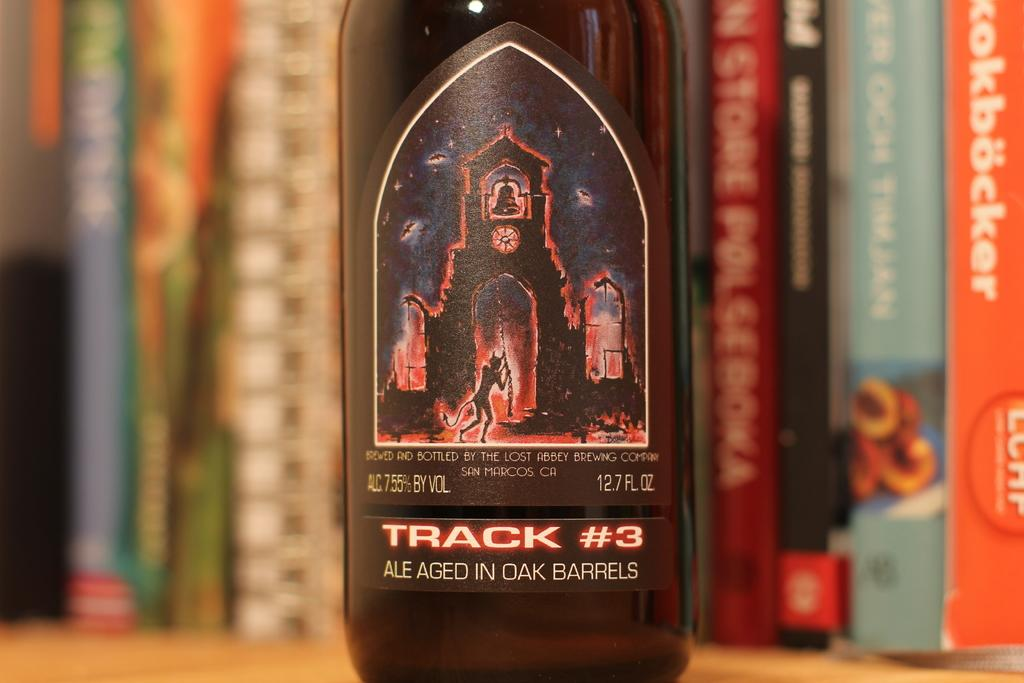What object can be seen in the image? There is a bottle in the image. Where is the bottle located? The bottle is placed on a brown table. What can be observed about the bottle's appearance? The bottle has a red and black color sticker. What can be seen in the background of the image? There are books visible in the background of the image. Can you describe the rainstorm happening outside the window in the image? There is no window or rainstorm visible in the image; it only shows a bottle on a brown table with a red and black sticker and books in the background. 